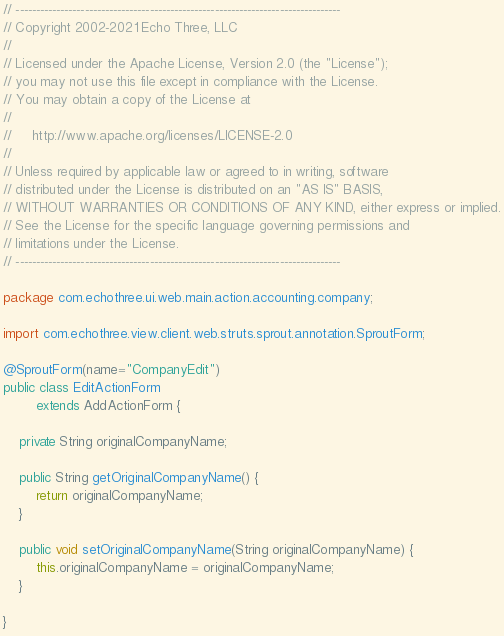Convert code to text. <code><loc_0><loc_0><loc_500><loc_500><_Java_>// --------------------------------------------------------------------------------
// Copyright 2002-2021 Echo Three, LLC
//
// Licensed under the Apache License, Version 2.0 (the "License");
// you may not use this file except in compliance with the License.
// You may obtain a copy of the License at
//
//     http://www.apache.org/licenses/LICENSE-2.0
//
// Unless required by applicable law or agreed to in writing, software
// distributed under the License is distributed on an "AS IS" BASIS,
// WITHOUT WARRANTIES OR CONDITIONS OF ANY KIND, either express or implied.
// See the License for the specific language governing permissions and
// limitations under the License.
// --------------------------------------------------------------------------------

package com.echothree.ui.web.main.action.accounting.company;

import com.echothree.view.client.web.struts.sprout.annotation.SproutForm;

@SproutForm(name="CompanyEdit")
public class EditActionForm
        extends AddActionForm {
    
    private String originalCompanyName;
    
    public String getOriginalCompanyName() {
        return originalCompanyName;
    }
    
    public void setOriginalCompanyName(String originalCompanyName) {
        this.originalCompanyName = originalCompanyName;
    }
    
}
</code> 